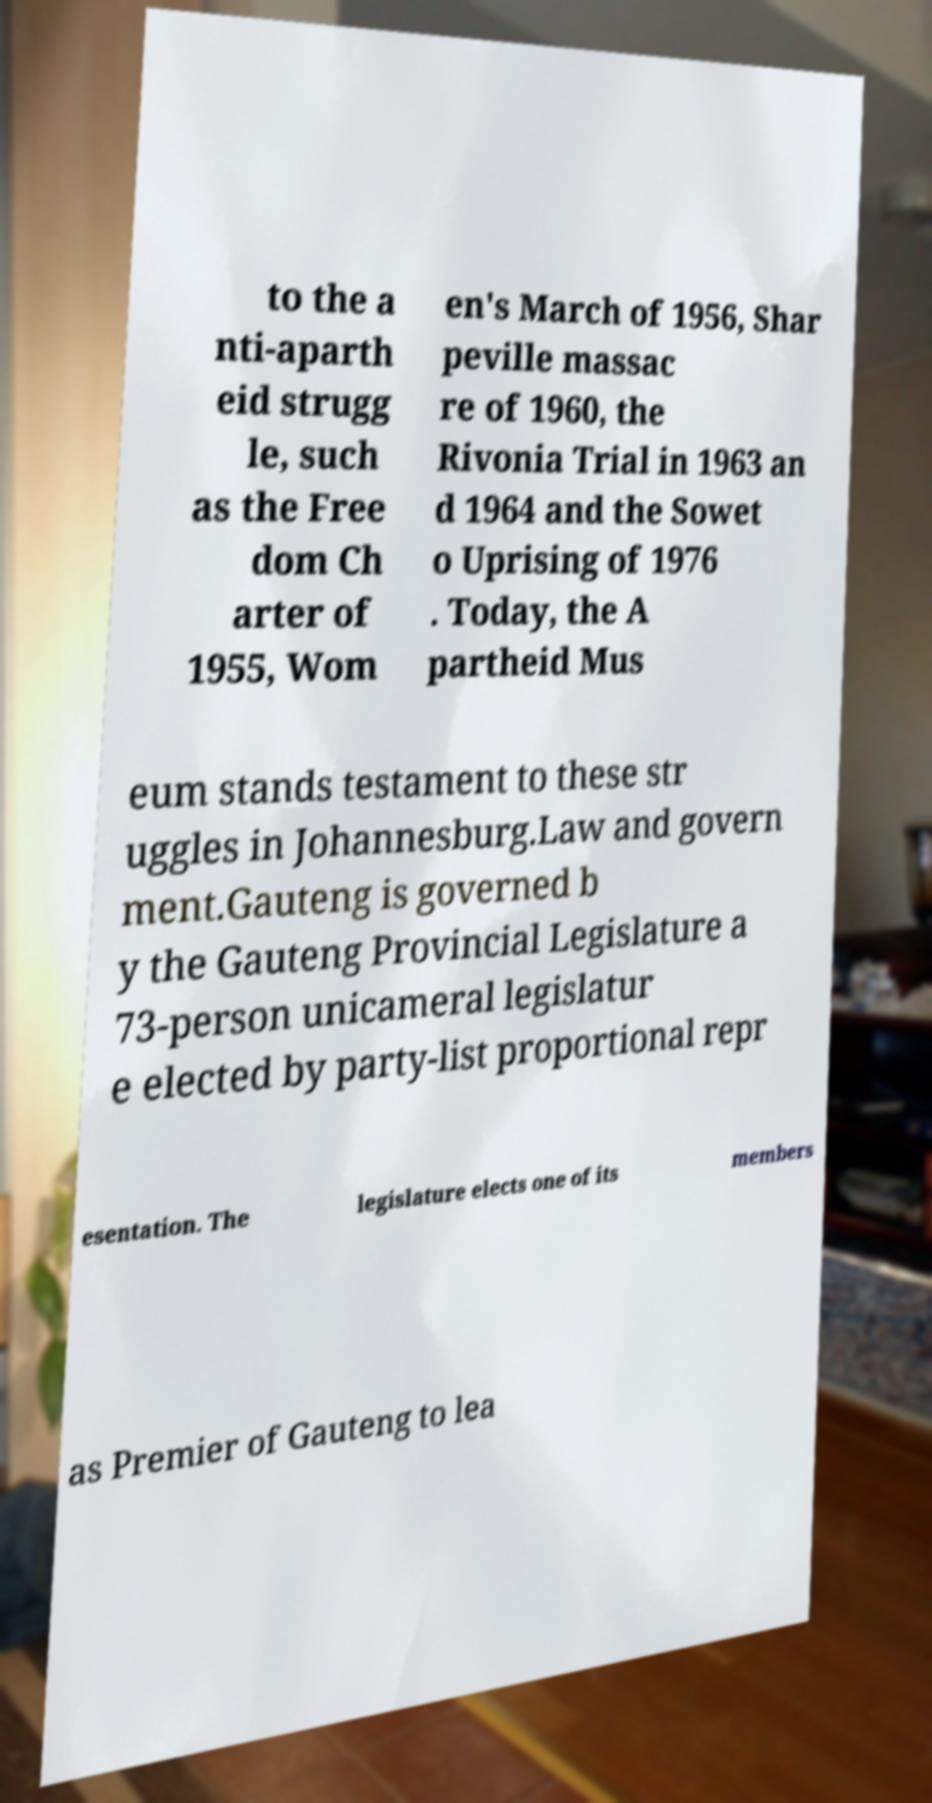Please read and relay the text visible in this image. What does it say? to the a nti-aparth eid strugg le, such as the Free dom Ch arter of 1955, Wom en's March of 1956, Shar peville massac re of 1960, the Rivonia Trial in 1963 an d 1964 and the Sowet o Uprising of 1976 . Today, the A partheid Mus eum stands testament to these str uggles in Johannesburg.Law and govern ment.Gauteng is governed b y the Gauteng Provincial Legislature a 73-person unicameral legislatur e elected by party-list proportional repr esentation. The legislature elects one of its members as Premier of Gauteng to lea 